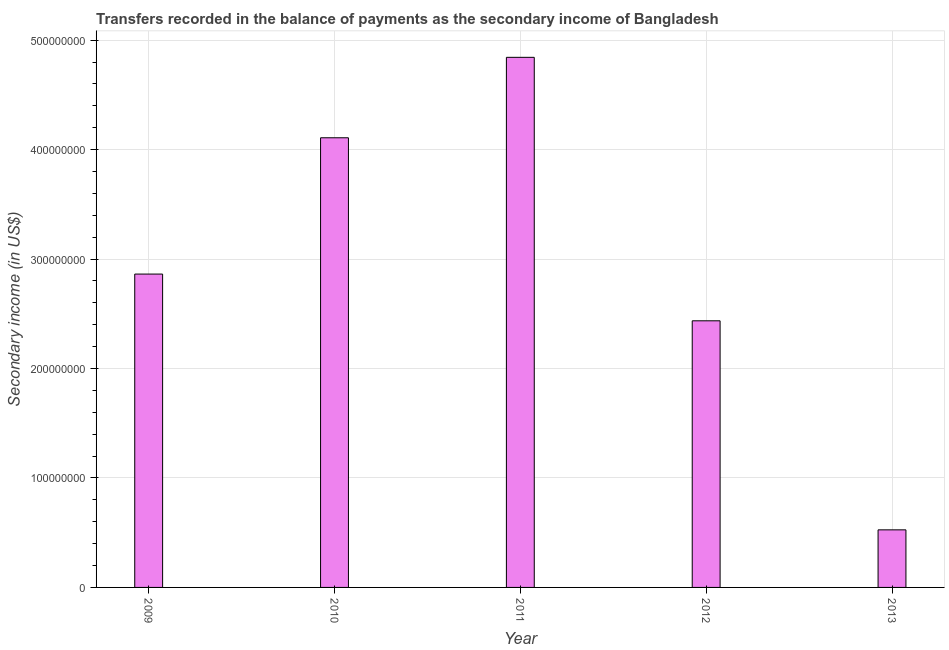Does the graph contain any zero values?
Give a very brief answer. No. What is the title of the graph?
Provide a short and direct response. Transfers recorded in the balance of payments as the secondary income of Bangladesh. What is the label or title of the Y-axis?
Give a very brief answer. Secondary income (in US$). What is the amount of secondary income in 2011?
Offer a very short reply. 4.84e+08. Across all years, what is the maximum amount of secondary income?
Your response must be concise. 4.84e+08. Across all years, what is the minimum amount of secondary income?
Make the answer very short. 5.26e+07. In which year was the amount of secondary income minimum?
Ensure brevity in your answer.  2013. What is the sum of the amount of secondary income?
Ensure brevity in your answer.  1.48e+09. What is the difference between the amount of secondary income in 2011 and 2013?
Your answer should be very brief. 4.32e+08. What is the average amount of secondary income per year?
Offer a terse response. 2.96e+08. What is the median amount of secondary income?
Provide a short and direct response. 2.86e+08. Do a majority of the years between 2009 and 2012 (inclusive) have amount of secondary income greater than 480000000 US$?
Your answer should be very brief. No. What is the ratio of the amount of secondary income in 2010 to that in 2011?
Give a very brief answer. 0.85. Is the difference between the amount of secondary income in 2010 and 2012 greater than the difference between any two years?
Provide a succinct answer. No. What is the difference between the highest and the second highest amount of secondary income?
Make the answer very short. 7.35e+07. Is the sum of the amount of secondary income in 2010 and 2012 greater than the maximum amount of secondary income across all years?
Your answer should be compact. Yes. What is the difference between the highest and the lowest amount of secondary income?
Provide a succinct answer. 4.32e+08. Are all the bars in the graph horizontal?
Offer a terse response. No. How many years are there in the graph?
Provide a short and direct response. 5. What is the Secondary income (in US$) in 2009?
Your answer should be compact. 2.86e+08. What is the Secondary income (in US$) in 2010?
Provide a succinct answer. 4.11e+08. What is the Secondary income (in US$) of 2011?
Make the answer very short. 4.84e+08. What is the Secondary income (in US$) in 2012?
Your answer should be very brief. 2.44e+08. What is the Secondary income (in US$) in 2013?
Your answer should be very brief. 5.26e+07. What is the difference between the Secondary income (in US$) in 2009 and 2010?
Make the answer very short. -1.25e+08. What is the difference between the Secondary income (in US$) in 2009 and 2011?
Provide a short and direct response. -1.98e+08. What is the difference between the Secondary income (in US$) in 2009 and 2012?
Your response must be concise. 4.27e+07. What is the difference between the Secondary income (in US$) in 2009 and 2013?
Your answer should be compact. 2.34e+08. What is the difference between the Secondary income (in US$) in 2010 and 2011?
Offer a very short reply. -7.35e+07. What is the difference between the Secondary income (in US$) in 2010 and 2012?
Give a very brief answer. 1.67e+08. What is the difference between the Secondary income (in US$) in 2010 and 2013?
Offer a very short reply. 3.58e+08. What is the difference between the Secondary income (in US$) in 2011 and 2012?
Offer a terse response. 2.41e+08. What is the difference between the Secondary income (in US$) in 2011 and 2013?
Your answer should be compact. 4.32e+08. What is the difference between the Secondary income (in US$) in 2012 and 2013?
Your response must be concise. 1.91e+08. What is the ratio of the Secondary income (in US$) in 2009 to that in 2010?
Give a very brief answer. 0.7. What is the ratio of the Secondary income (in US$) in 2009 to that in 2011?
Provide a short and direct response. 0.59. What is the ratio of the Secondary income (in US$) in 2009 to that in 2012?
Your answer should be compact. 1.18. What is the ratio of the Secondary income (in US$) in 2009 to that in 2013?
Offer a terse response. 5.44. What is the ratio of the Secondary income (in US$) in 2010 to that in 2011?
Your answer should be very brief. 0.85. What is the ratio of the Secondary income (in US$) in 2010 to that in 2012?
Ensure brevity in your answer.  1.69. What is the ratio of the Secondary income (in US$) in 2010 to that in 2013?
Your answer should be compact. 7.81. What is the ratio of the Secondary income (in US$) in 2011 to that in 2012?
Your response must be concise. 1.99. What is the ratio of the Secondary income (in US$) in 2011 to that in 2013?
Your answer should be compact. 9.21. What is the ratio of the Secondary income (in US$) in 2012 to that in 2013?
Your response must be concise. 4.63. 